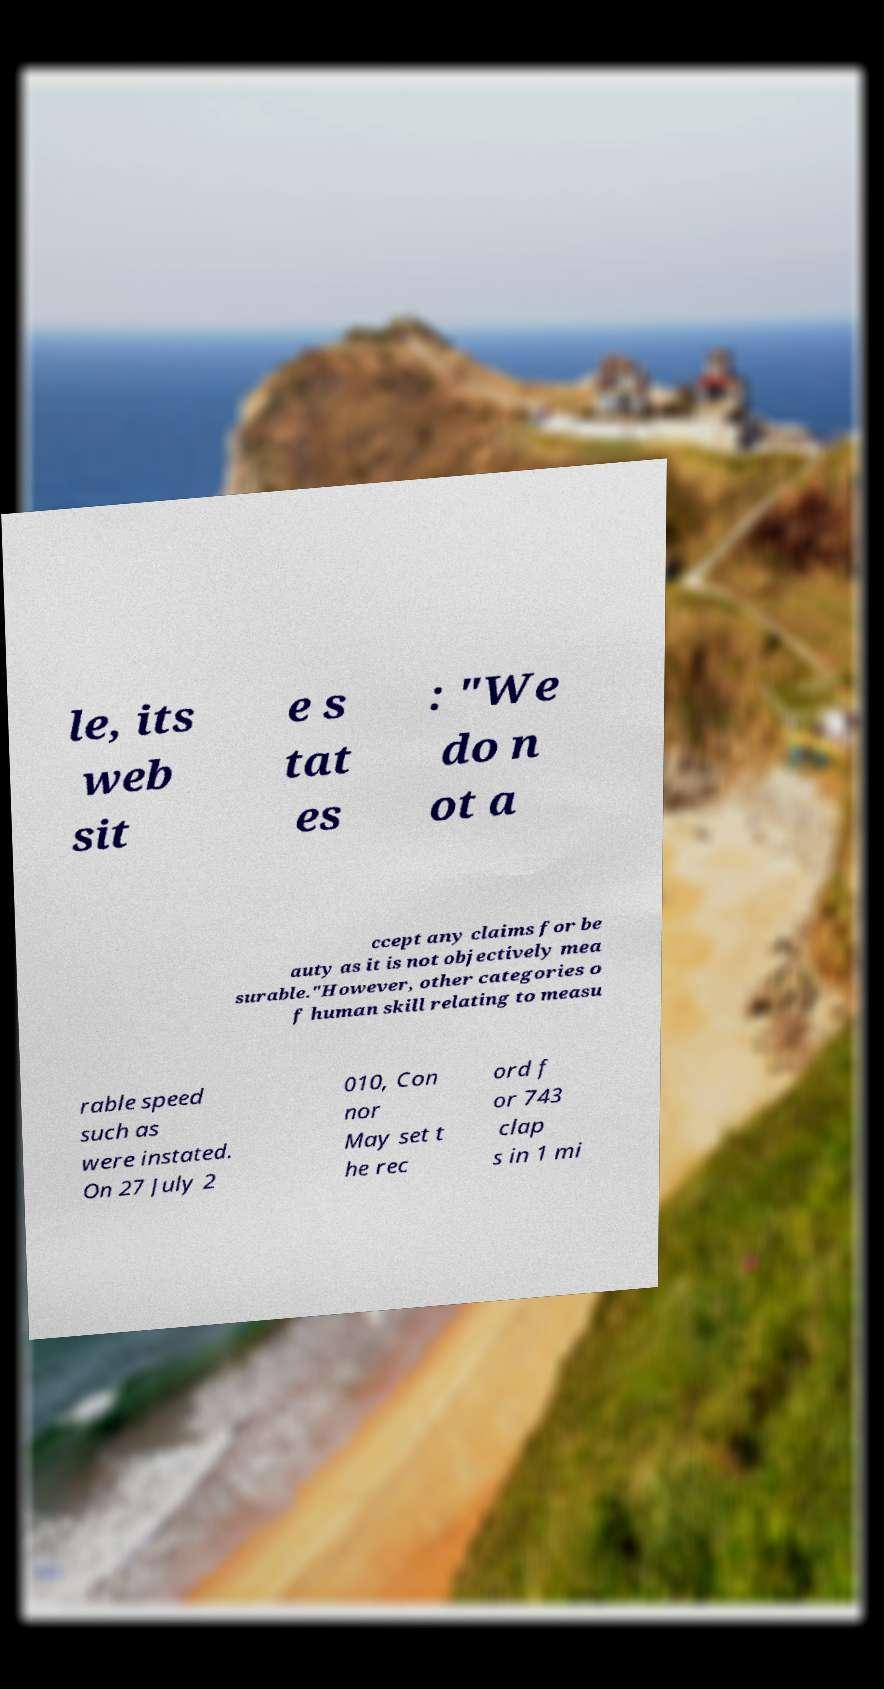Please identify and transcribe the text found in this image. le, its web sit e s tat es : "We do n ot a ccept any claims for be auty as it is not objectively mea surable."However, other categories o f human skill relating to measu rable speed such as were instated. On 27 July 2 010, Con nor May set t he rec ord f or 743 clap s in 1 mi 